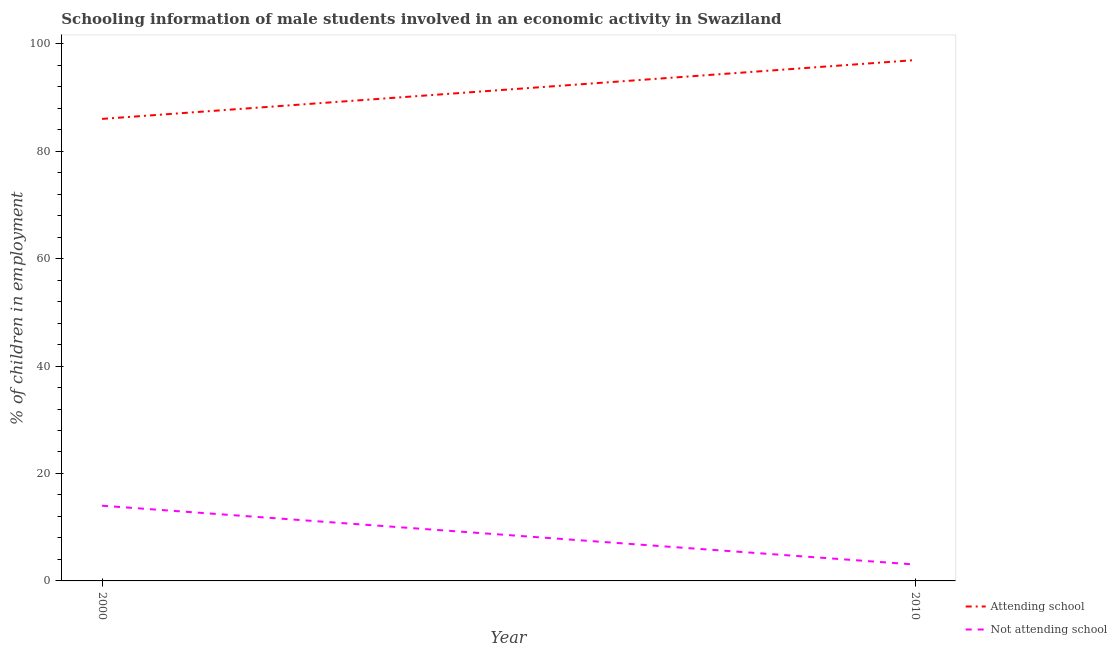How many different coloured lines are there?
Provide a succinct answer. 2. Does the line corresponding to percentage of employed males who are attending school intersect with the line corresponding to percentage of employed males who are not attending school?
Your response must be concise. No. Is the number of lines equal to the number of legend labels?
Keep it short and to the point. Yes. What is the percentage of employed males who are not attending school in 2000?
Your response must be concise. 14. Across all years, what is the maximum percentage of employed males who are not attending school?
Provide a short and direct response. 14. Across all years, what is the minimum percentage of employed males who are not attending school?
Ensure brevity in your answer.  3.05. What is the total percentage of employed males who are attending school in the graph?
Your answer should be very brief. 182.95. What is the difference between the percentage of employed males who are attending school in 2000 and that in 2010?
Make the answer very short. -10.95. What is the difference between the percentage of employed males who are not attending school in 2010 and the percentage of employed males who are attending school in 2000?
Provide a short and direct response. -82.95. What is the average percentage of employed males who are attending school per year?
Ensure brevity in your answer.  91.47. In the year 2000, what is the difference between the percentage of employed males who are attending school and percentage of employed males who are not attending school?
Make the answer very short. 72. What is the ratio of the percentage of employed males who are not attending school in 2000 to that in 2010?
Offer a very short reply. 4.59. Is the percentage of employed males who are attending school strictly less than the percentage of employed males who are not attending school over the years?
Ensure brevity in your answer.  No. How many lines are there?
Provide a succinct answer. 2. How many years are there in the graph?
Keep it short and to the point. 2. Are the values on the major ticks of Y-axis written in scientific E-notation?
Offer a terse response. No. Does the graph contain any zero values?
Provide a short and direct response. No. What is the title of the graph?
Give a very brief answer. Schooling information of male students involved in an economic activity in Swaziland. Does "Highest 20% of population" appear as one of the legend labels in the graph?
Keep it short and to the point. No. What is the label or title of the X-axis?
Make the answer very short. Year. What is the label or title of the Y-axis?
Provide a succinct answer. % of children in employment. What is the % of children in employment in Attending school in 2000?
Your answer should be very brief. 86. What is the % of children in employment of Not attending school in 2000?
Provide a succinct answer. 14. What is the % of children in employment in Attending school in 2010?
Your response must be concise. 96.95. What is the % of children in employment of Not attending school in 2010?
Offer a very short reply. 3.05. Across all years, what is the maximum % of children in employment in Attending school?
Your answer should be very brief. 96.95. Across all years, what is the minimum % of children in employment of Attending school?
Offer a terse response. 86. Across all years, what is the minimum % of children in employment of Not attending school?
Make the answer very short. 3.05. What is the total % of children in employment of Attending school in the graph?
Make the answer very short. 182.95. What is the total % of children in employment of Not attending school in the graph?
Offer a very short reply. 17.05. What is the difference between the % of children in employment of Attending school in 2000 and that in 2010?
Provide a short and direct response. -10.95. What is the difference between the % of children in employment of Not attending school in 2000 and that in 2010?
Offer a terse response. 10.95. What is the difference between the % of children in employment of Attending school in 2000 and the % of children in employment of Not attending school in 2010?
Provide a succinct answer. 82.95. What is the average % of children in employment of Attending school per year?
Make the answer very short. 91.47. What is the average % of children in employment in Not attending school per year?
Your answer should be very brief. 8.53. In the year 2000, what is the difference between the % of children in employment of Attending school and % of children in employment of Not attending school?
Provide a succinct answer. 72. In the year 2010, what is the difference between the % of children in employment in Attending school and % of children in employment in Not attending school?
Your answer should be very brief. 93.9. What is the ratio of the % of children in employment in Attending school in 2000 to that in 2010?
Offer a terse response. 0.89. What is the ratio of the % of children in employment in Not attending school in 2000 to that in 2010?
Provide a short and direct response. 4.59. What is the difference between the highest and the second highest % of children in employment in Attending school?
Offer a very short reply. 10.95. What is the difference between the highest and the second highest % of children in employment in Not attending school?
Offer a terse response. 10.95. What is the difference between the highest and the lowest % of children in employment in Attending school?
Keep it short and to the point. 10.95. What is the difference between the highest and the lowest % of children in employment in Not attending school?
Your answer should be compact. 10.95. 